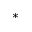<formula> <loc_0><loc_0><loc_500><loc_500>^ { * }</formula> 